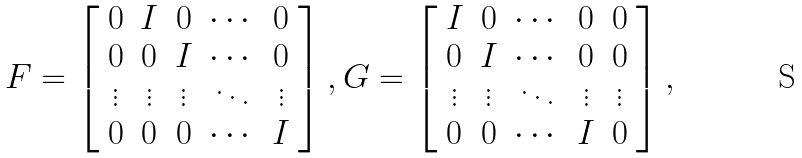<formula> <loc_0><loc_0><loc_500><loc_500>F = \left [ \begin{array} { c c c c c } 0 & I & 0 & \cdots & 0 \\ 0 & 0 & I & \cdots & 0 \\ \vdots & \vdots & \vdots & \ddots & \vdots \\ 0 & 0 & 0 & \cdots & I \end{array} \right ] , G = \left [ \begin{array} { c c c c c } I & 0 & \cdots & 0 & 0 \\ 0 & I & \cdots & 0 & 0 \\ \vdots & \vdots & \ddots & \vdots & \vdots \\ 0 & 0 & \cdots & I & 0 \end{array} \right ] ,</formula> 